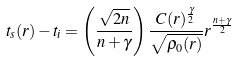<formula> <loc_0><loc_0><loc_500><loc_500>t _ { s } ( r ) - t _ { i } = \left ( \frac { \sqrt { 2 n } } { n + \gamma } \right ) \frac { C ( r ) ^ { \frac { \gamma } { 2 } } } { \sqrt { \rho _ { 0 } ( r ) } } r ^ { \frac { n + \gamma } { 2 } }</formula> 